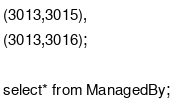<code> <loc_0><loc_0><loc_500><loc_500><_SQL_>(3013,3015),
(3013,3016);

select* from ManagedBy;</code> 